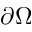<formula> <loc_0><loc_0><loc_500><loc_500>\partial \Omega</formula> 